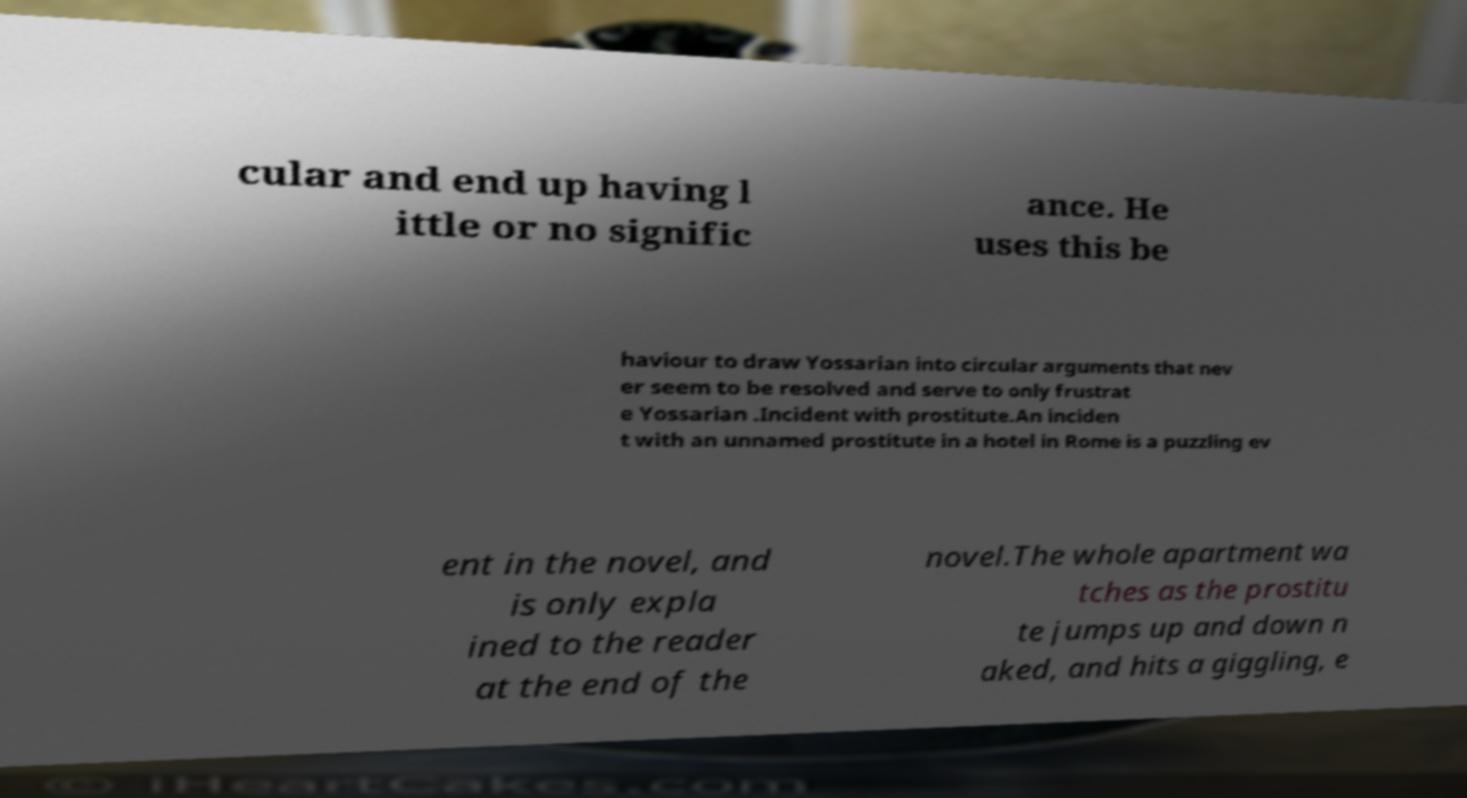Could you extract and type out the text from this image? cular and end up having l ittle or no signific ance. He uses this be haviour to draw Yossarian into circular arguments that nev er seem to be resolved and serve to only frustrat e Yossarian .Incident with prostitute.An inciden t with an unnamed prostitute in a hotel in Rome is a puzzling ev ent in the novel, and is only expla ined to the reader at the end of the novel.The whole apartment wa tches as the prostitu te jumps up and down n aked, and hits a giggling, e 